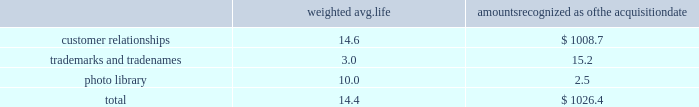Westrock company notes to consolidated financial statements fffd ( continued ) the table summarizes the weighted average life and the allocation to intangible assets recognized in the mps acquisition , excluding goodwill ( in millions ) : weighted avg .
Amounts recognized as the acquisition .
None of the intangibles has significant residual value .
We are amortizing the customer relationship intangibles over estimated useful lives ranging from 13 to 16 years based on a straight-line basis because the amortization pattern was not reliably determinable .
Star pizza acquisition on march 13 , 2017 , we completed the star pizza acquisition .
The transaction provided us with a leadership position in the fast growing small-run pizza box market and increases our vertical integration .
The purchase price was $ 34.6 million , net of a $ 0.7 million working capital settlement .
We have fully integrated the approximately 22000 tons of containerboard used by star pizza annually .
We have included the financial results of the acquired assets since the date of the acquisition in our corrugated packaging segment .
The purchase price allocation for the acquisition primarily included $ 24.8 million of customer relationship intangible assets and $ 2.2 million of goodwill .
We are amortizing the customer relationship intangibles over 10 years based on a straight-line basis because the amortization pattern was not reliably determinable .
The fair value assigned to goodwill is primarily attributable to buyer-specific synergies expected to arise after the acquisition ( e.g. , enhanced reach of the combined organization and other synergies ) , and the assembled work force .
The goodwill and intangibles are amortizable for income tax purposes .
Packaging acquisition on january 19 , 2016 , we completed the packaging acquisition .
The entities acquired provide value-added folding carton and litho-laminated display packaging solutions .
The purchase price was $ 94.1 million , net of cash received of $ 1.7 million , a working capital settlement and a $ 3.5 million escrow receipt in the first quarter of fiscal 2017 .
The transaction is subject to an election under section 338 ( h ) ( 10 ) of the code that increases the u.s .
Tax basis in the acquired u.s .
Entities .
We believe the transaction has provided us with attractive and complementary customers , markets and facilities .
We have included the financial results of the acquired entities since the date of the acquisition in our consumer packaging segment .
The purchase price allocation for the acquisition primarily included $ 55.0 million of property , plant and equipment , $ 10.5 million of customer relationship intangible assets , $ 9.3 million of goodwill and $ 25.8 million of liabilities , including $ 1.3 million of debt .
We are amortizing the customer relationship intangibles over estimated useful lives ranging from 9 to 15 years based on a straight-line basis because the amortization pattern was not reliably determinable .
The fair value assigned to goodwill is primarily attributable to buyer-specific synergies expected to arise after the acquisition ( e.g. , enhanced reach of the combined organization and other synergies ) , and the assembled work force .
The goodwill and intangibles of the u.s .
Entities are amortizable for income tax purposes .
Sp fiber on october 1 , 2015 , we completed the sp fiber acquisition in a stock purchase .
The transaction included the acquisition of mills located in dublin , ga and newberg , or , which produce lightweight recycled containerboard and kraft and bag paper .
The newberg mill also produced newsprint .
As part of the transaction , we also acquired sp fiber's 48% ( 48 % ) interest in gps .
Gps is a joint venture providing steam to the dublin mill and electricity to georgia power .
The purchase price was $ 278.8 million , net of cash received of $ 9.2 million and a working capital .
What percent of the overall purchase value of star pizza was in customer relationship intangible assets and goodwill? 
Computations: ((2.2 + 24.8) / 34.6)
Answer: 0.78035. 